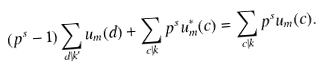Convert formula to latex. <formula><loc_0><loc_0><loc_500><loc_500>( p ^ { s } - 1 ) \sum _ { d | k ^ { \prime } } u _ { m } ( d ) + \sum _ { c | k } p ^ { s } u _ { m } ^ { * } ( c ) = \sum _ { c | k } p ^ { s } u _ { m } ( c ) .</formula> 